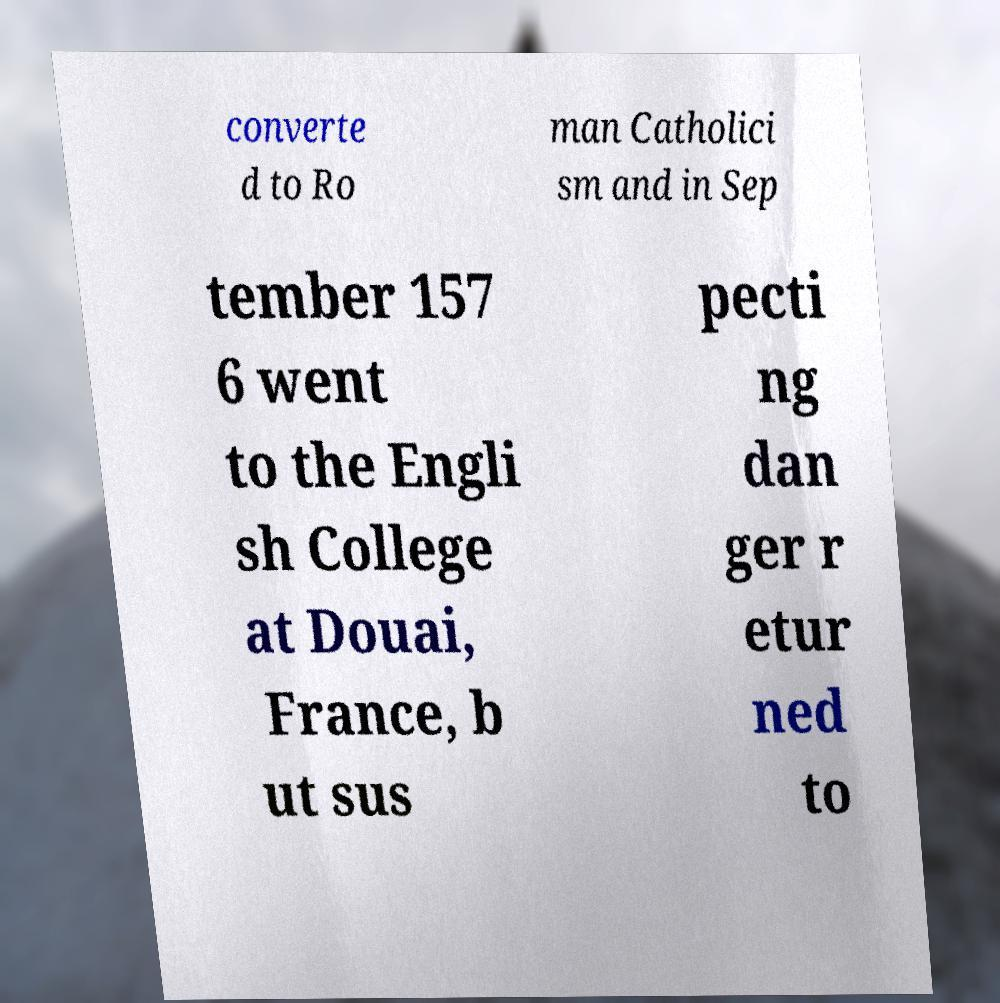Please identify and transcribe the text found in this image. converte d to Ro man Catholici sm and in Sep tember 157 6 went to the Engli sh College at Douai, France, b ut sus pecti ng dan ger r etur ned to 